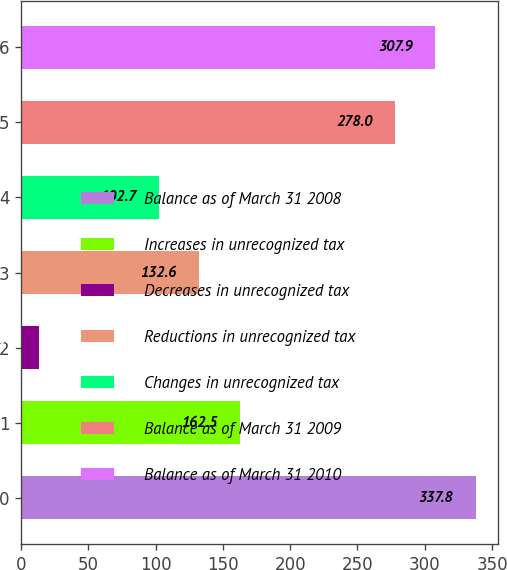<chart> <loc_0><loc_0><loc_500><loc_500><bar_chart><fcel>Balance as of March 31 2008<fcel>Increases in unrecognized tax<fcel>Decreases in unrecognized tax<fcel>Reductions in unrecognized tax<fcel>Changes in unrecognized tax<fcel>Balance as of March 31 2009<fcel>Balance as of March 31 2010<nl><fcel>337.8<fcel>162.5<fcel>13<fcel>132.6<fcel>102.7<fcel>278<fcel>307.9<nl></chart> 